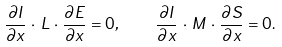Convert formula to latex. <formula><loc_0><loc_0><loc_500><loc_500>\frac { \partial I } { \partial x } \, \cdot \, L \, \cdot \, \frac { \partial E } { \partial x } = 0 , \quad \frac { \partial I } { \partial x } \, \cdot \, M \, \cdot \, \frac { \partial S } { \partial x } = 0 .</formula> 